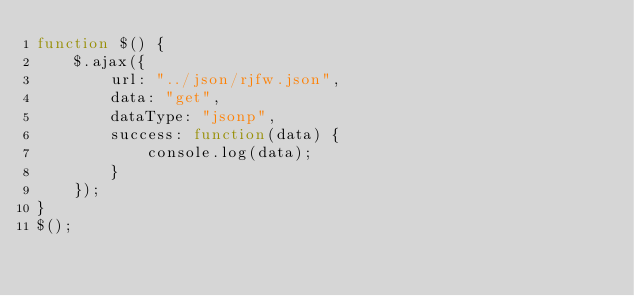<code> <loc_0><loc_0><loc_500><loc_500><_JavaScript_>function $() {
    $.ajax({
        url: "../json/rjfw.json",
        data: "get",
        dataType: "jsonp",
        success: function(data) {
            console.log(data);
        }
    });
}
$();</code> 